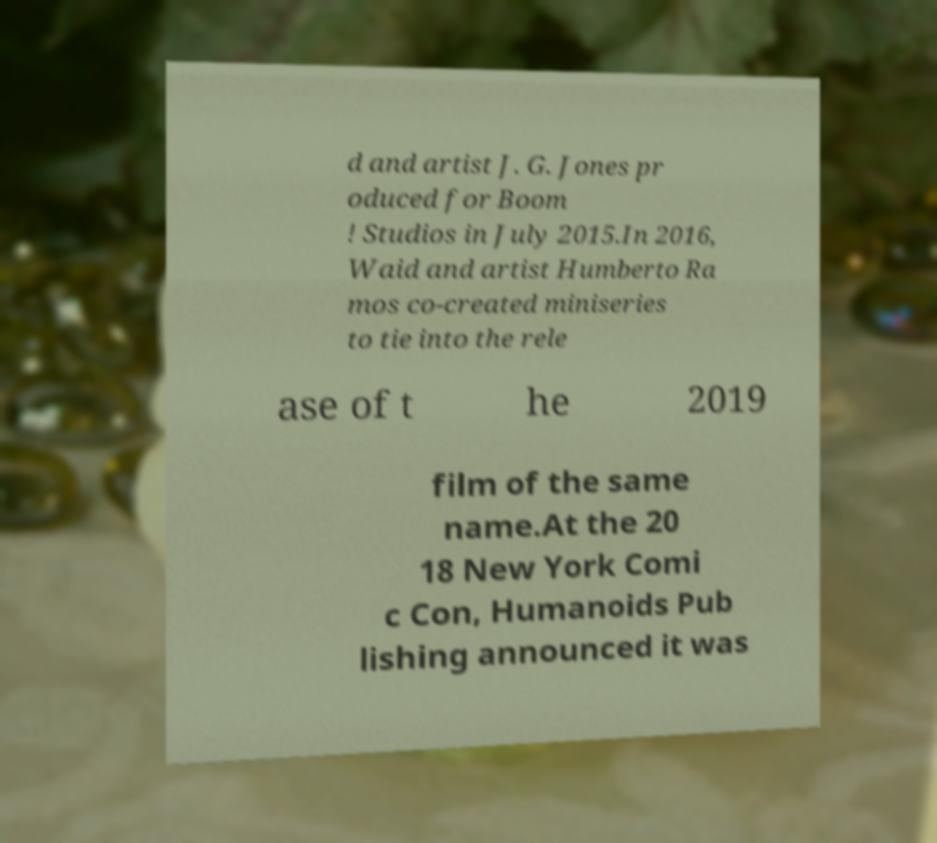I need the written content from this picture converted into text. Can you do that? d and artist J. G. Jones pr oduced for Boom ! Studios in July 2015.In 2016, Waid and artist Humberto Ra mos co-created miniseries to tie into the rele ase of t he 2019 film of the same name.At the 20 18 New York Comi c Con, Humanoids Pub lishing announced it was 